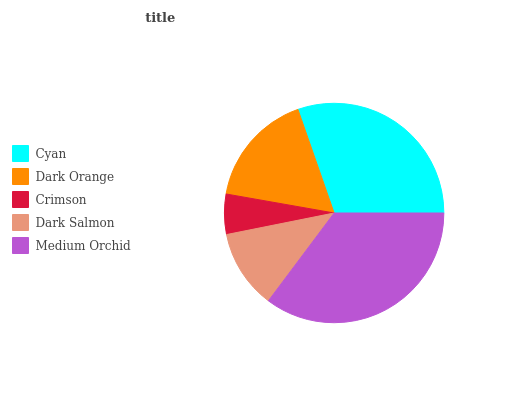Is Crimson the minimum?
Answer yes or no. Yes. Is Medium Orchid the maximum?
Answer yes or no. Yes. Is Dark Orange the minimum?
Answer yes or no. No. Is Dark Orange the maximum?
Answer yes or no. No. Is Cyan greater than Dark Orange?
Answer yes or no. Yes. Is Dark Orange less than Cyan?
Answer yes or no. Yes. Is Dark Orange greater than Cyan?
Answer yes or no. No. Is Cyan less than Dark Orange?
Answer yes or no. No. Is Dark Orange the high median?
Answer yes or no. Yes. Is Dark Orange the low median?
Answer yes or no. Yes. Is Medium Orchid the high median?
Answer yes or no. No. Is Cyan the low median?
Answer yes or no. No. 